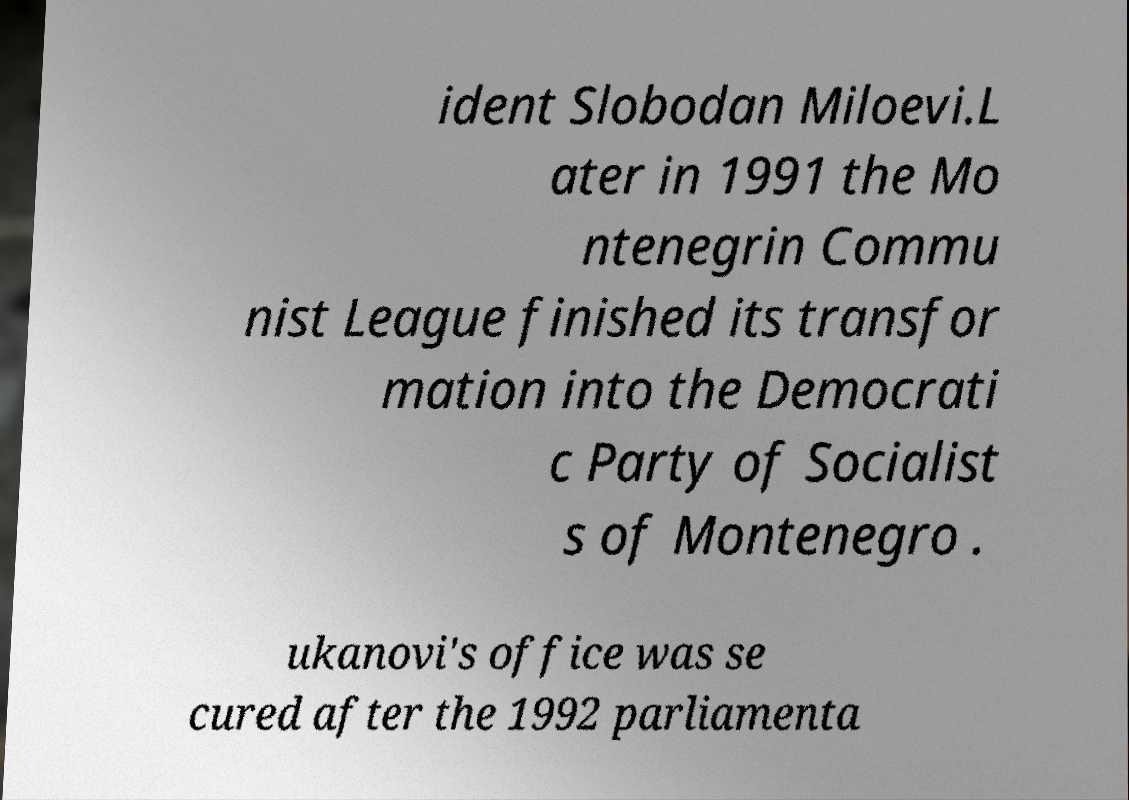I need the written content from this picture converted into text. Can you do that? ident Slobodan Miloevi.L ater in 1991 the Mo ntenegrin Commu nist League finished its transfor mation into the Democrati c Party of Socialist s of Montenegro . ukanovi's office was se cured after the 1992 parliamenta 